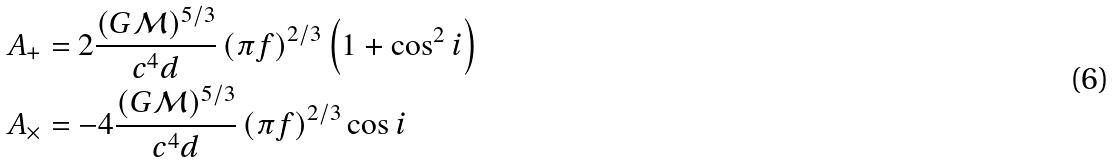<formula> <loc_0><loc_0><loc_500><loc_500>A _ { + } & = 2 \frac { ( G \mathcal { M } ) ^ { 5 / 3 } } { c ^ { 4 } d } \left ( \pi f \right ) ^ { 2 / 3 } \left ( 1 + \cos ^ { 2 } i \right ) \\ A _ { \times } & = - 4 \frac { ( G \mathcal { M } ) ^ { 5 / 3 } } { c ^ { 4 } d } \left ( \pi f \right ) ^ { 2 / 3 } \cos i</formula> 